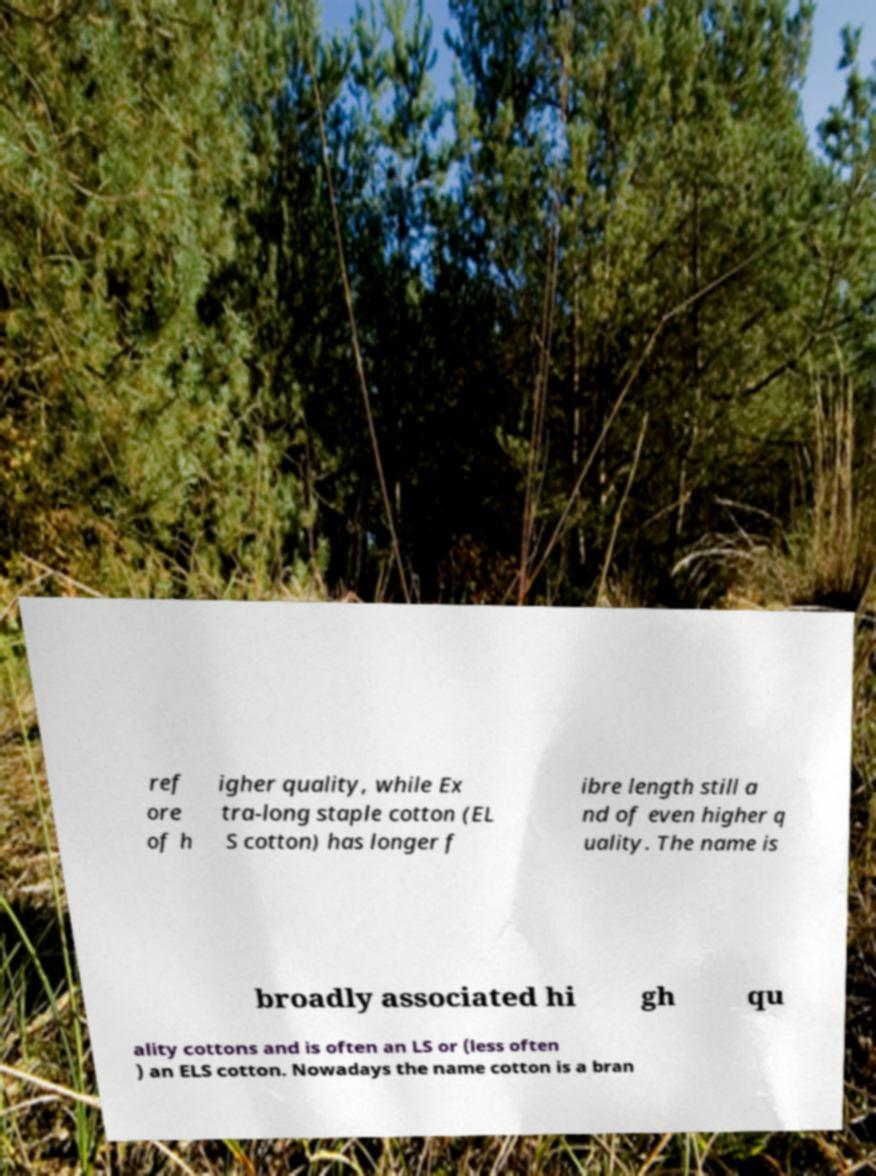Please read and relay the text visible in this image. What does it say? ref ore of h igher quality, while Ex tra-long staple cotton (EL S cotton) has longer f ibre length still a nd of even higher q uality. The name is broadly associated hi gh qu ality cottons and is often an LS or (less often ) an ELS cotton. Nowadays the name cotton is a bran 